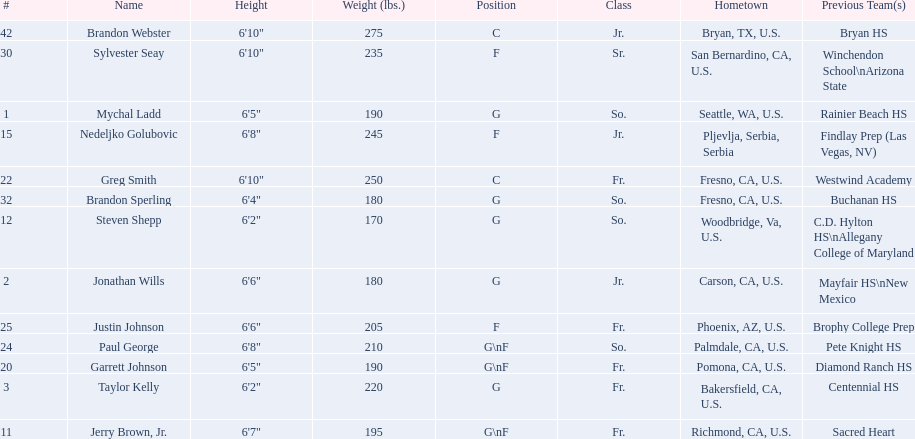Which player who is only a forward (f) is the shortest? Justin Johnson. 